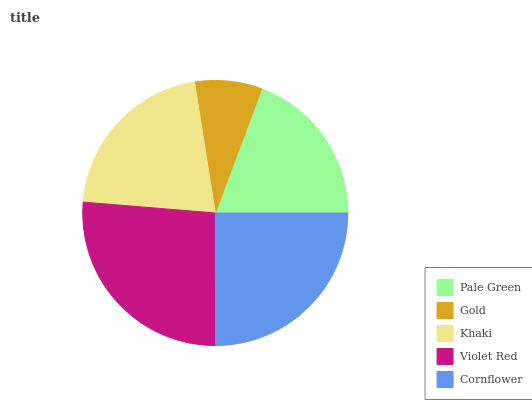Is Gold the minimum?
Answer yes or no. Yes. Is Violet Red the maximum?
Answer yes or no. Yes. Is Khaki the minimum?
Answer yes or no. No. Is Khaki the maximum?
Answer yes or no. No. Is Khaki greater than Gold?
Answer yes or no. Yes. Is Gold less than Khaki?
Answer yes or no. Yes. Is Gold greater than Khaki?
Answer yes or no. No. Is Khaki less than Gold?
Answer yes or no. No. Is Khaki the high median?
Answer yes or no. Yes. Is Khaki the low median?
Answer yes or no. Yes. Is Gold the high median?
Answer yes or no. No. Is Pale Green the low median?
Answer yes or no. No. 